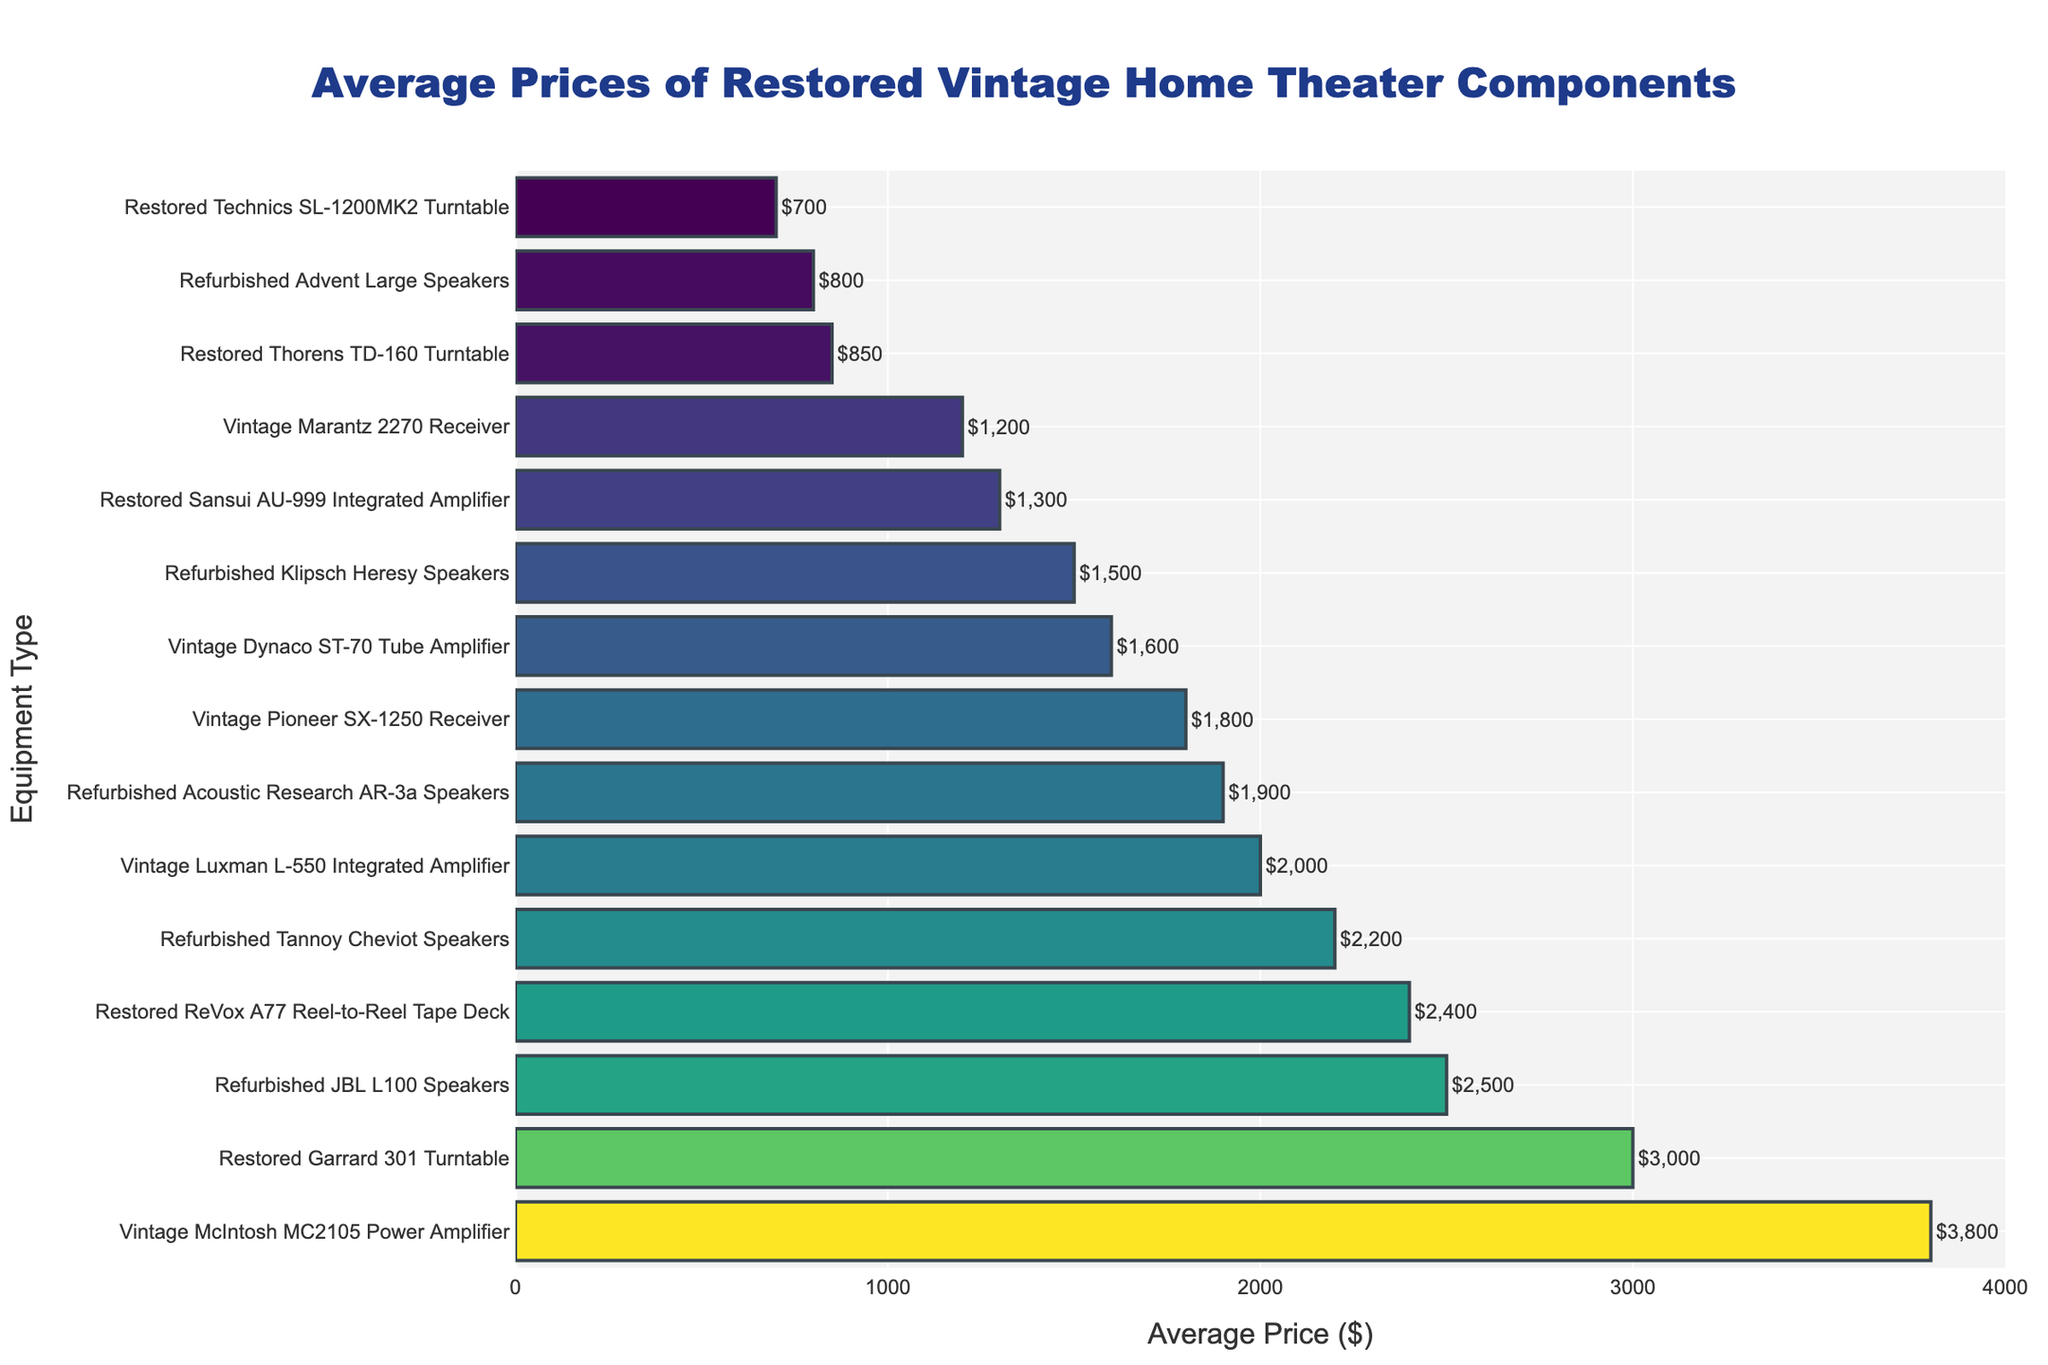What's the most expensive component? The most expensive component has the longest bar in the chart with the highest value on the x-axis. The Vintage McIntosh MC2105 Power Amplifier is priced at $3800, making it the most expensive.
Answer: Vintage McIntosh MC2105 Power Amplifier What's the least expensive turntable listed? Identify the bars associated with turntables and compare their lengths. The Restored Technics SL-1200MK2 Turntable has the shortest bar among the turntables, priced at $700.
Answer: Restored Technics SL-1200MK2 Turntable How much more expensive is the Vintage Pioneer SX-1250 Receiver compared to the Restored Thorens TD-160 Turntable? The bar for the Vintage Pioneer SX-1250 Receiver shows $1800 and the Restored Thorens TD-160 Turntable shows $850. Subtract 850 from 1800.
Answer: $950 What is the combined average price of the Refurbished JBL L100 Speakers and the Restored Garrard 301 Turntable? The Refurbished JBL L100 Speakers are $2500 and the Restored Garrard 301 Turntable is $3000. Add these two values.
Answer: $5500 Which equipment type has a price closest to $2000? Identify bars with values around $2000. The Vintage Luxman L-550 Integrated Amplifier is priced exactly at $2000.
Answer: Vintage Luxman L-550 Integrated Amplifier How many of the listed components have an average price above $2000? Count the number of bars that extend to values greater than $2000 on the x-axis.
Answer: 6 What is the average price difference between the most expensive and least expensive components? The most expensive component is the Vintage McIntosh MC2105 Power Amplifier at $3800 and the least expensive is the Restored Technics SL-1200MK2 Turntable at $700. Subtract 700 from 3800.
Answer: $3100 Which turntable is more expensive – the Restored Garrard 301 Turntable or the Restored Thorens TD-160 Turntable? Compare the lengths of the bars for the Restored Garrard 301 Turntable ($3000) and the Restored Thorens TD-160 Turntable ($850).
Answer: Restored Garrard 301 Turntable 